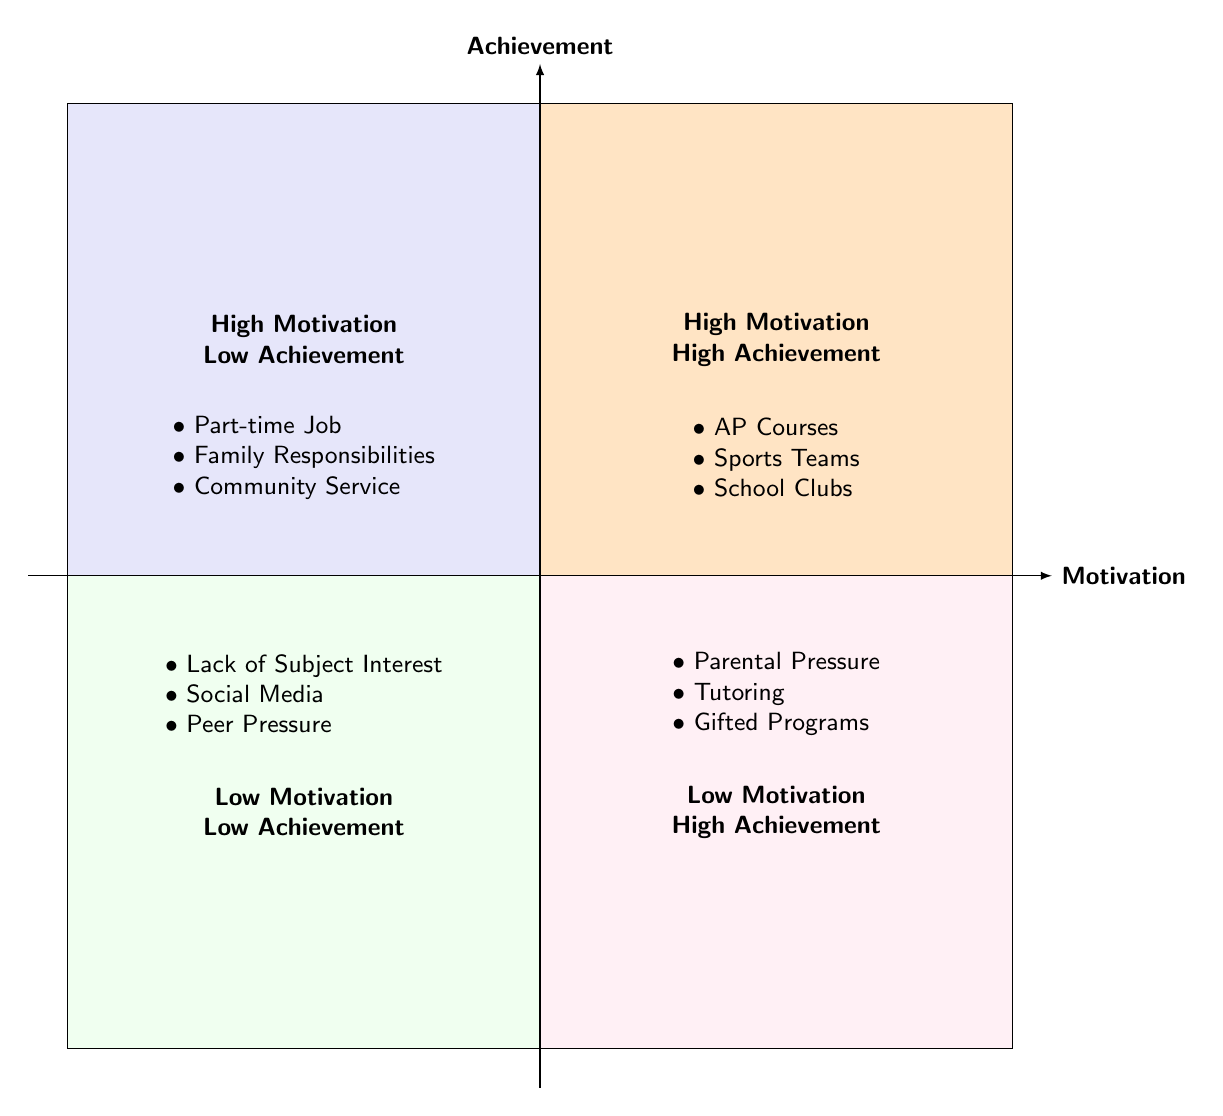What items are in the "High Motivation - High Achievement" quadrant? The question asks for specific items listed in the quadrant labeled "High Motivation - High Achievement." According to the diagram, the items listed are "Participation in AP Courses," "Engagement in Sports Teams," and "Membership in School Clubs."
Answer: AP Courses, Sports Teams, School Clubs How many items are found in the "Low Motivation - Low Achievement" quadrant? The question requires counting the number of items in the "Low Motivation - Low Achievement" quadrant. The items listed are "Lack of Interest in Subjects," "Social Media Distractions," and "Peer Pressure and Social Environment," which totals three items.
Answer: 3 Which quadrant contains "Tutoring and Private Lessons"? This question is asking for the location of the item "Tutoring and Private Lessons." After examining the quadrants, it is found in the "Low Motivation - High Achievement" quadrant.
Answer: Low Motivation - High Achievement What two factors contribute to "High Motivation - Low Achievement"? The question requests the identification of two factors from the "High Motivation - Low Achievement" quadrant. The identified items are "Part-time Job Commitments" and "Family Responsibilities."
Answer: Part-time Job Commitments, Family Responsibilities Which quadrant has "Parental Pressure and Expectations"? The question asks for the specific quadrant in which "Parental Pressure and Expectations" is located. Upon review, this item appears in the "Low Motivation - High Achievement" quadrant.
Answer: Low Motivation - High Achievement Are there any items in the "High Motivation - High Achievement" quadrant that are part of student organizations? This question seeks to identify if there are any items related to student organizations in the "High Motivation - High Achievement" quadrant. The item "Membership in School Clubs" indicates that there are items related to student organizations.
Answer: Yes Which quadrant features "Social Media Distractions"? The query is about the specific quadrant that includes "Social Media Distractions." This item is found in the "Low Motivation - Low Achievement" quadrant.
Answer: Low Motivation - Low Achievement 